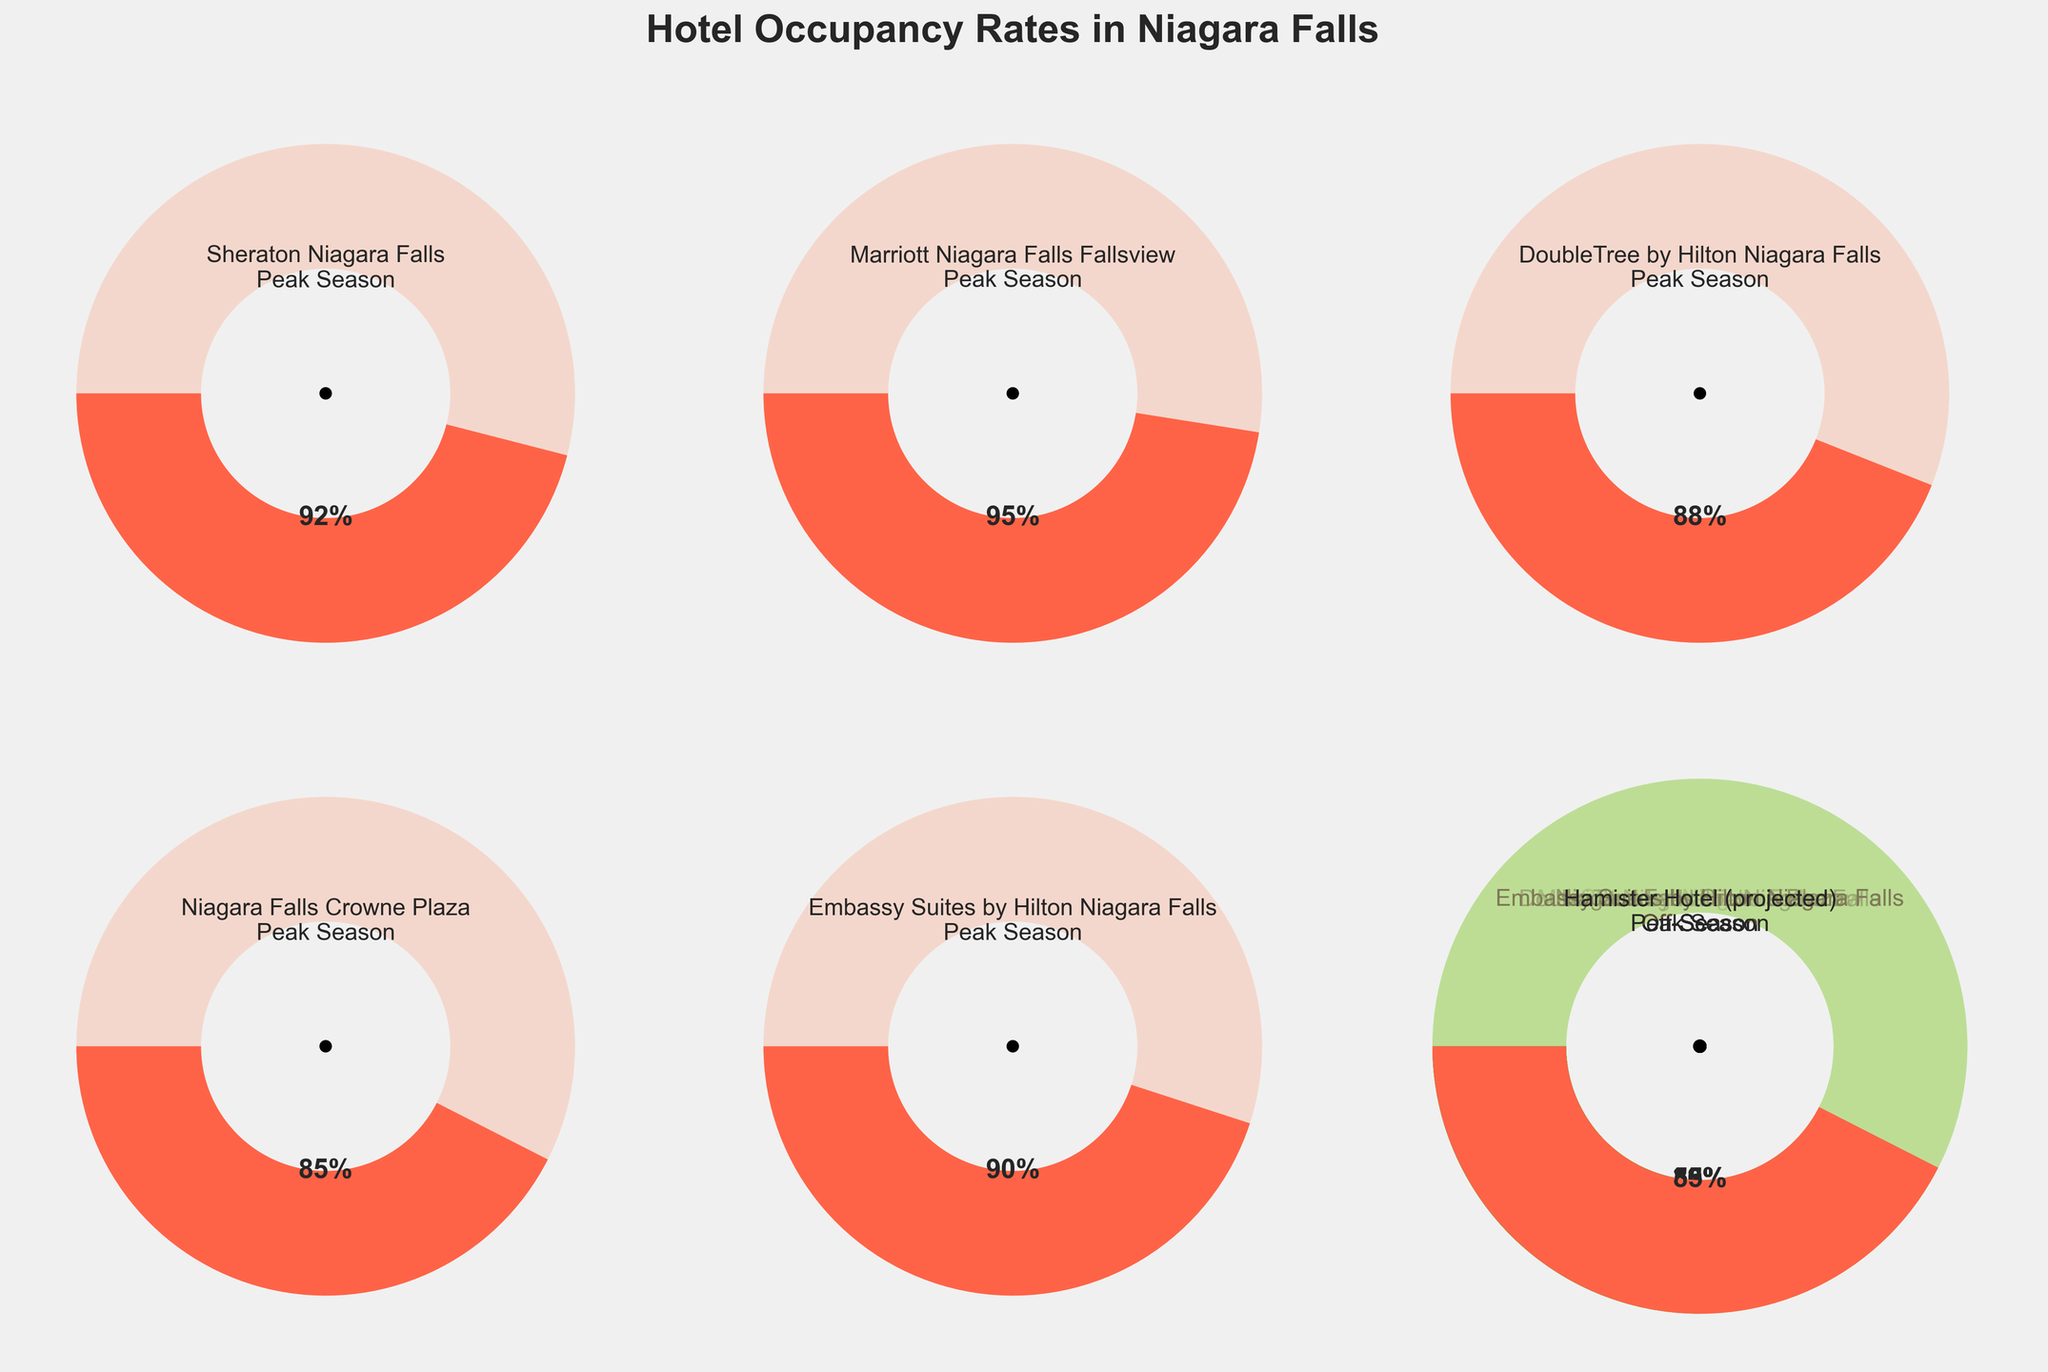What is the peak season occupancy rate for the Hamister Hotel? Look for the gauge labeled "Hamister Hotel" and note the percentage displayed for the peak season section.
Answer: 85% What is the difference in occupancy rates between peak season and off-season for the Marriott Niagara Falls Fallsview? Identify the Marriott gauge for peak season and off-season, subtract the Off-Season percentage from the Peak Season percentage (95% - 50%).
Answer: 45% Which hotel has the highest peak season occupancy rate? Compare the peak season rates for all hotels and identify the highest value. The Marriott Niagara Falls Fallsview has the highest rate at 95%.
Answer: Marriott Niagara Falls Fallsview What is the average off-season occupancy rate across all hotels listed? Sum up all the off-season occupancy rates and divide by the number of hotels: (45 + 50 + 40 + 38 + 48 + 42) / 6.
Answer: 43.83% How does the off-season occupancy rate of the Sheraton Niagara Falls compare to the peak season occupancy rate of the Niagara Falls Crowne Plaza? Compare the off-season rate of Sheraton (45%) with the peak season rate of Niagara Falls Crowne Plaza (85%).
Answer: Sheraton off-season is lower What is the combined average occupancy rate (peak + off-season) for Embassy Suites by Hilton Niagara Falls? Add the peak and off-season rates for Embassy Suites and then average: (90 + 48) / 2.
Answer: 69% Which hotel has the smallest difference in occupancy rates between peak season and off-season? Calculate the differences for all hotels and identify the smallest one: Sheraton (92-45), Marriott (95-50), DoubleTree (88-40), Crowne Plaza (85-38), Embassy Suites (90-48), Hamister (85-42).
Answer: Hamister Hotel (43%) Is there any hotel with an off-season occupancy rate higher than 50%? Check the gauges for all hotels’ off-season rates. No hotel has an off-season rate higher than 50%.
Answer: No 